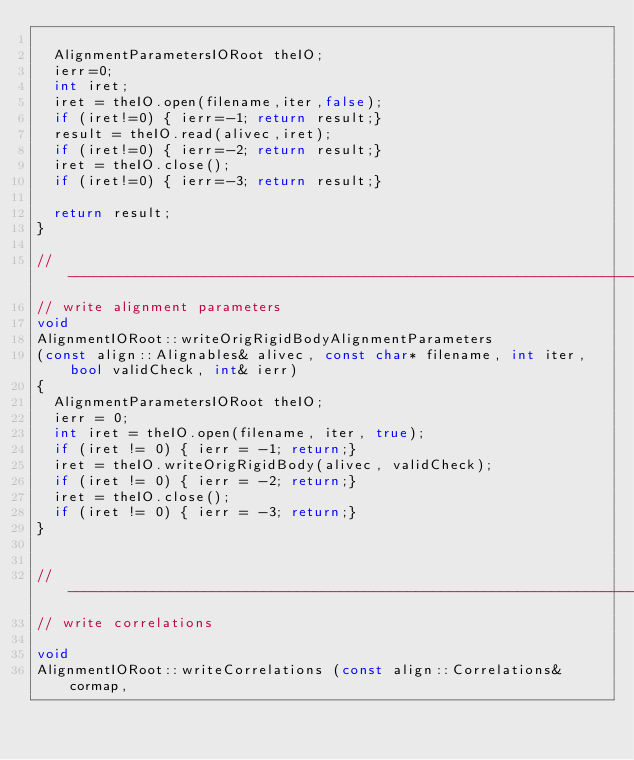<code> <loc_0><loc_0><loc_500><loc_500><_C++_>
  AlignmentParametersIORoot theIO;
  ierr=0;
  int iret;
  iret = theIO.open(filename,iter,false);
  if (iret!=0) { ierr=-1; return result;}
  result = theIO.read(alivec,iret);
  if (iret!=0) { ierr=-2; return result;}
  iret = theIO.close();
  if (iret!=0) { ierr=-3; return result;}

  return result;
}

// ----------------------------------------------------------------------------
// write alignment parameters 
void
AlignmentIORoot::writeOrigRigidBodyAlignmentParameters
(const align::Alignables& alivec, const char* filename, int iter, bool validCheck, int& ierr)
{
  AlignmentParametersIORoot theIO;
  ierr = 0;
  int iret = theIO.open(filename, iter, true);
  if (iret != 0) { ierr = -1; return;}
  iret = theIO.writeOrigRigidBody(alivec, validCheck);
  if (iret != 0) { ierr = -2; return;}
  iret = theIO.close();
  if (iret != 0) { ierr = -3; return;}
}


// ----------------------------------------------------------------------------
// write correlations

void 
AlignmentIORoot::writeCorrelations (const align::Correlations& cormap, </code> 